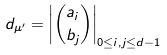<formula> <loc_0><loc_0><loc_500><loc_500>d _ { \mu ^ { \prime } } = \left | { a _ { i } \choose b _ { j } } \right | _ { 0 \leq i , j \leq d - 1 }</formula> 